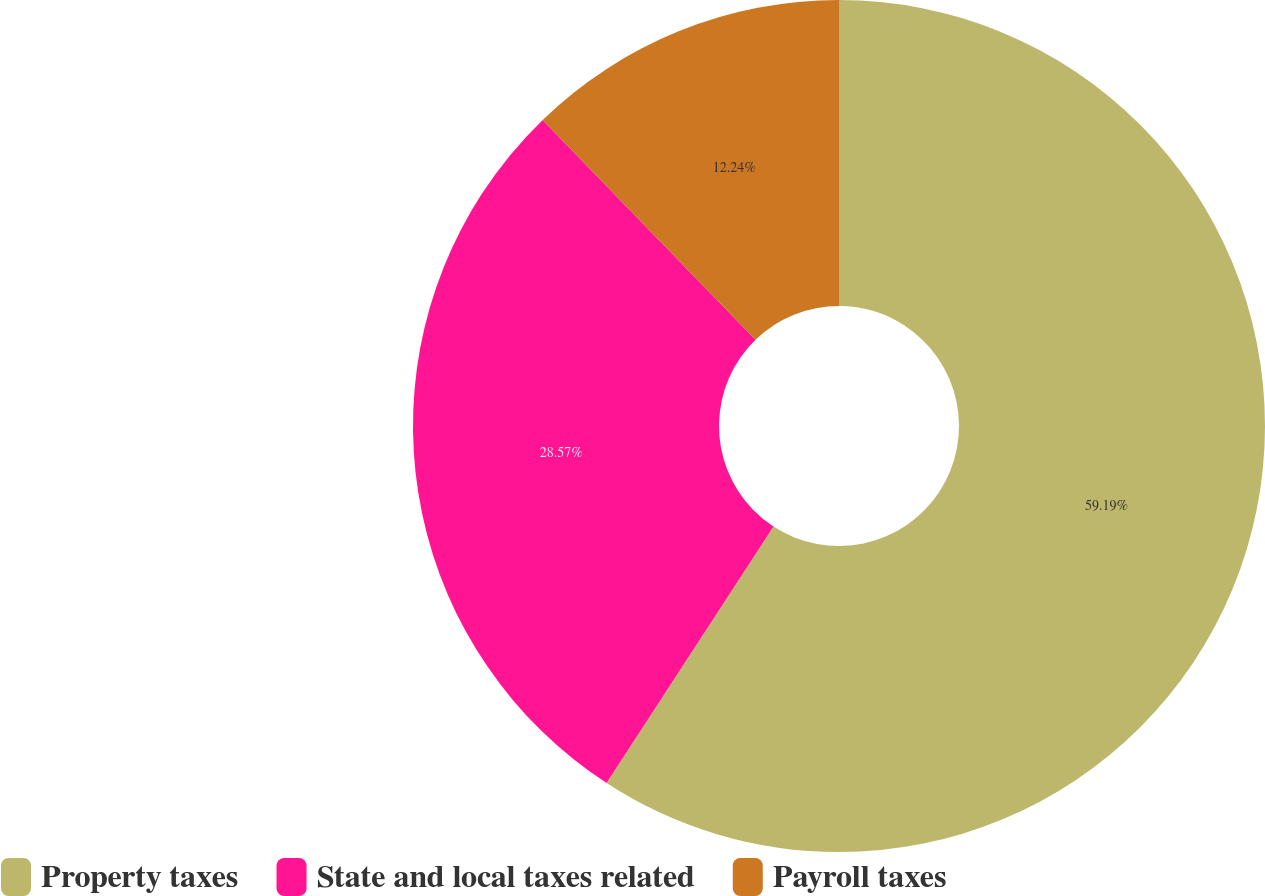<chart> <loc_0><loc_0><loc_500><loc_500><pie_chart><fcel>Property taxes<fcel>State and local taxes related<fcel>Payroll taxes<nl><fcel>59.18%<fcel>28.57%<fcel>12.24%<nl></chart> 